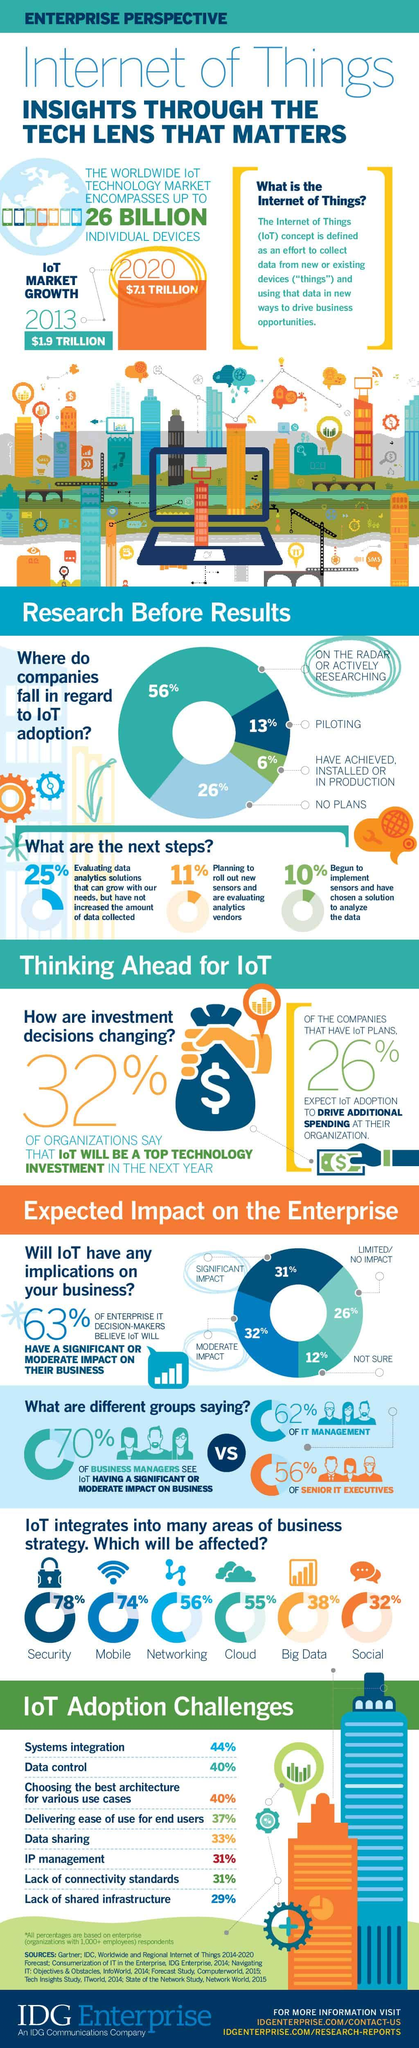Outline some significant characteristics in this image. A significant 38% of Big Data is currently integrated into the Internet of Things (IoT). A significant percentage of mobile devices are not integrated into the Internet of Things (IoT). In fact, 26% of mobile devices are not connected to the IoT. According to a study, 78% of IoT devices have security integrated into them. 